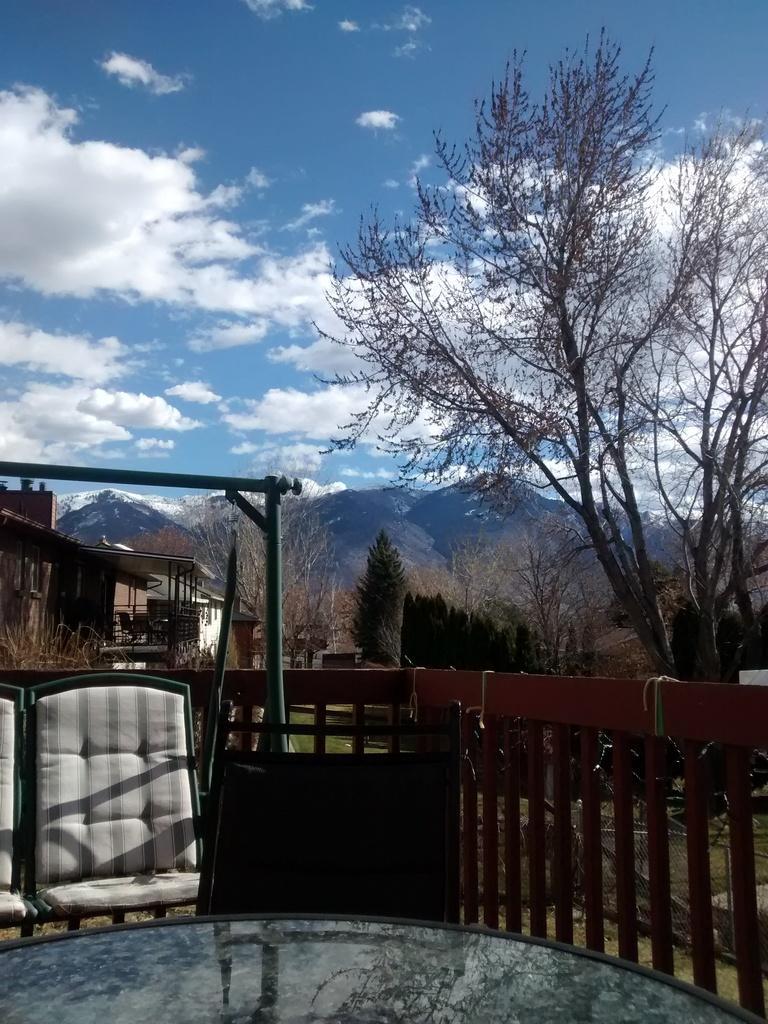Please provide a concise description of this image. In this picture I can see buildings, trees, hill and a blue cloudy sky and I can see a glass table and a chair swing cradle and I can see wooden fence. 